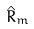<formula> <loc_0><loc_0><loc_500><loc_500>\hat { R } _ { m }</formula> 